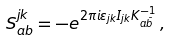<formula> <loc_0><loc_0><loc_500><loc_500>S _ { a b } ^ { j k } = - e ^ { 2 \pi i \varepsilon _ { j k } I _ { j k } K _ { a \bar { b } } ^ { - 1 } } \, ,</formula> 